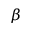Convert formula to latex. <formula><loc_0><loc_0><loc_500><loc_500>\beta</formula> 